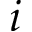<formula> <loc_0><loc_0><loc_500><loc_500>i</formula> 